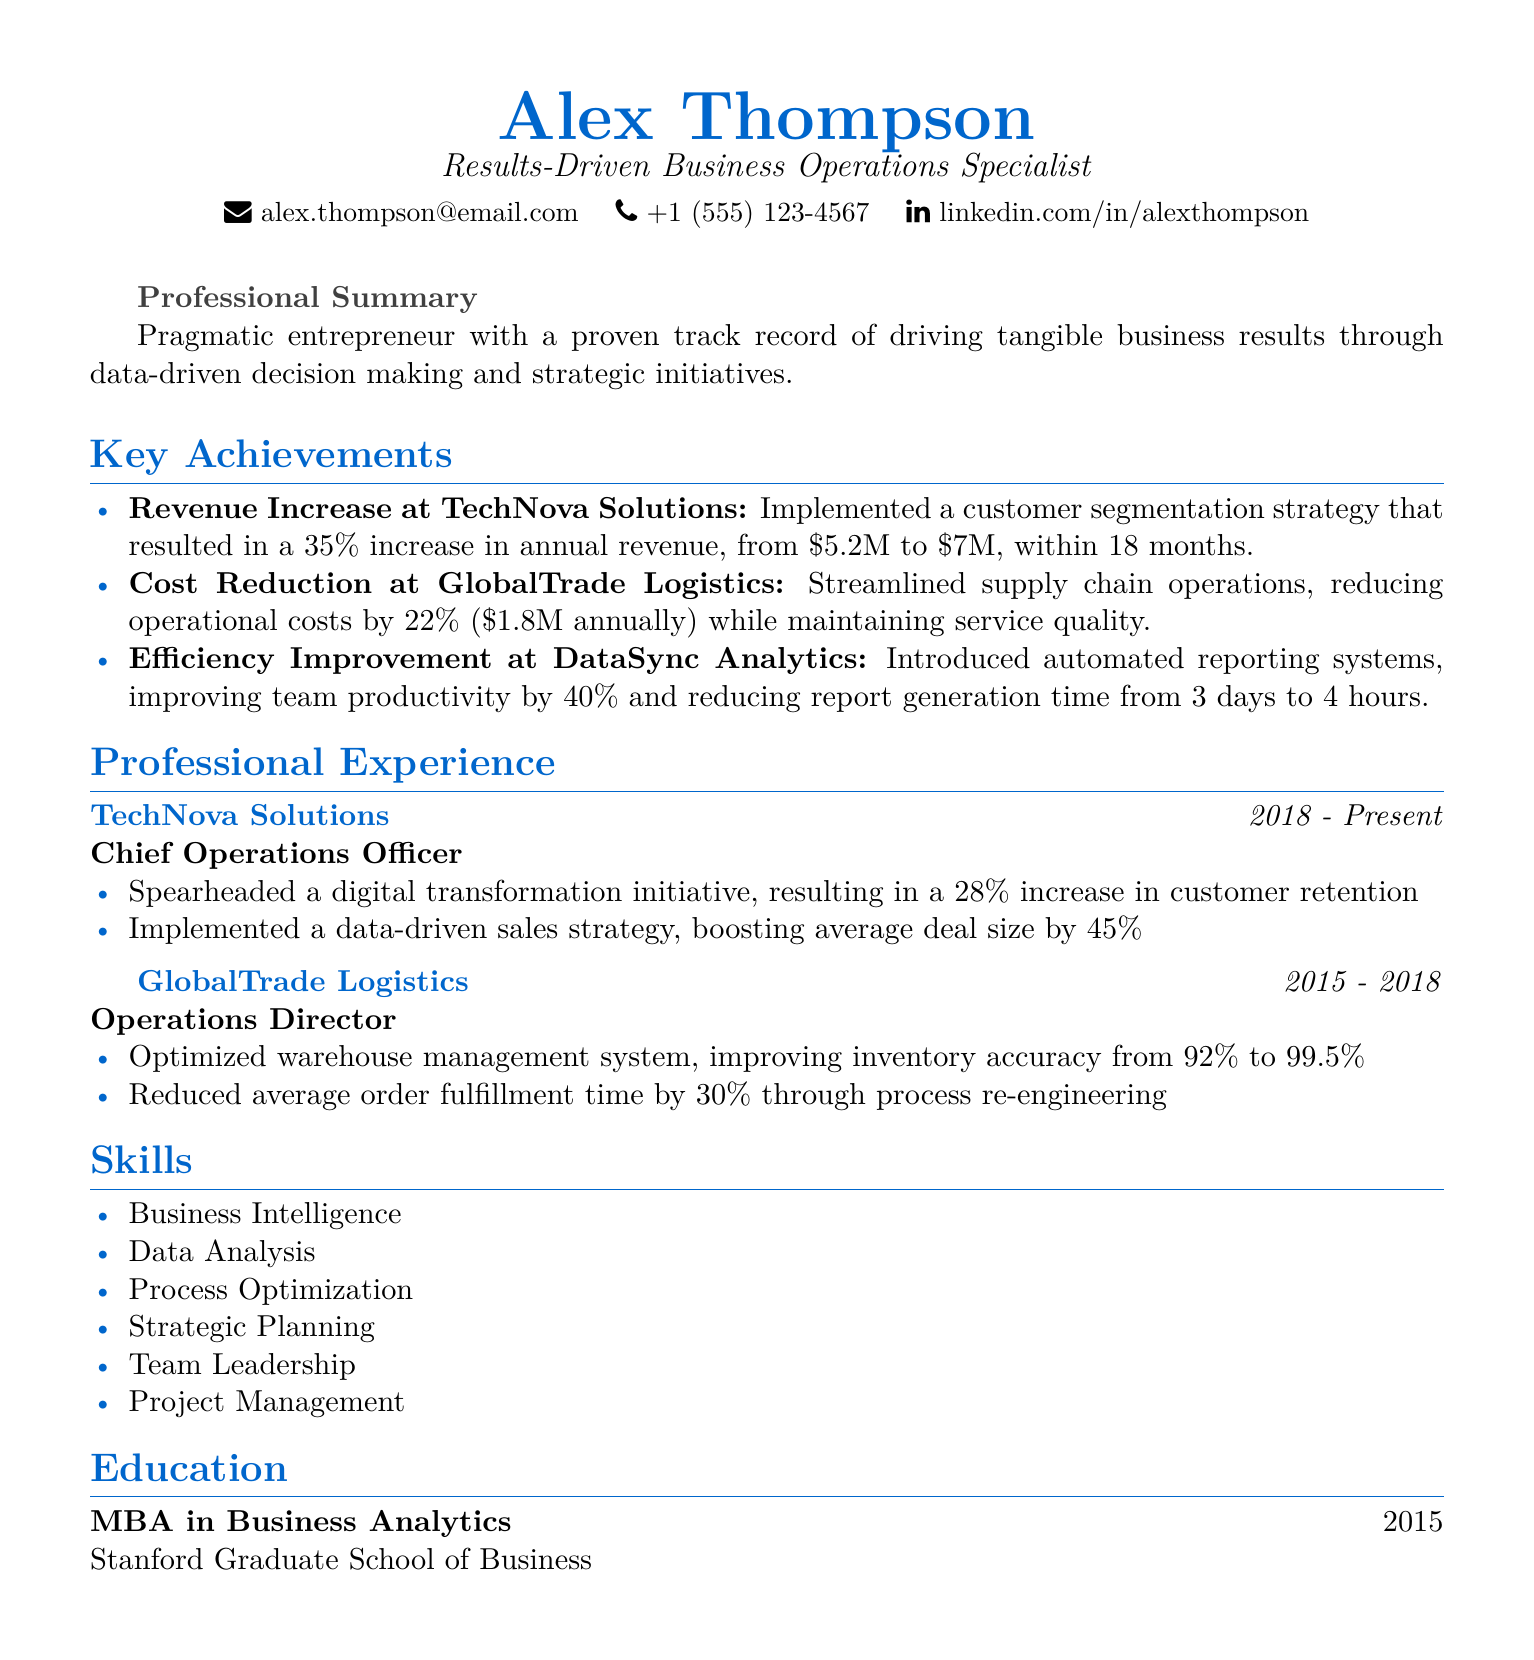What is the name of the person? The document provides the name of the individual at the beginning, which is Alex Thompson.
Answer: Alex Thompson What is the title of the individual? The title relates to the person's professional identity as indicated in the document.
Answer: Results-Driven Business Operations Specialist What is the email address listed? The email address is part of the contact information provided in the personal info section.
Answer: alex.thompson@email.com What was the revenue increase percentage at TechNova Solutions? The document mentions a specific percentage increase in revenue due to a strategy implemented.
Answer: 35% What role did Alex Thompson hold at GlobalTrade Logistics? The position is defined under the professional experience section for that organization.
Answer: Operations Director How much was the annual cost reduction at GlobalTrade Logistics? The cost reduction figure is explicitly mentioned under key achievements.
Answer: $1.8M What is the duration of Alex Thompson's employment at TechNova Solutions? The employment duration is specified in the professional experience section for that company.
Answer: 2018 - Present What degree does Alex Thompson hold? The education section identifies the academic qualification of the individual.
Answer: MBA in Business Analytics By how much did team productivity improve at DataSync Analytics? The document details the improvement percentage achieved through specific initiatives.
Answer: 40% 